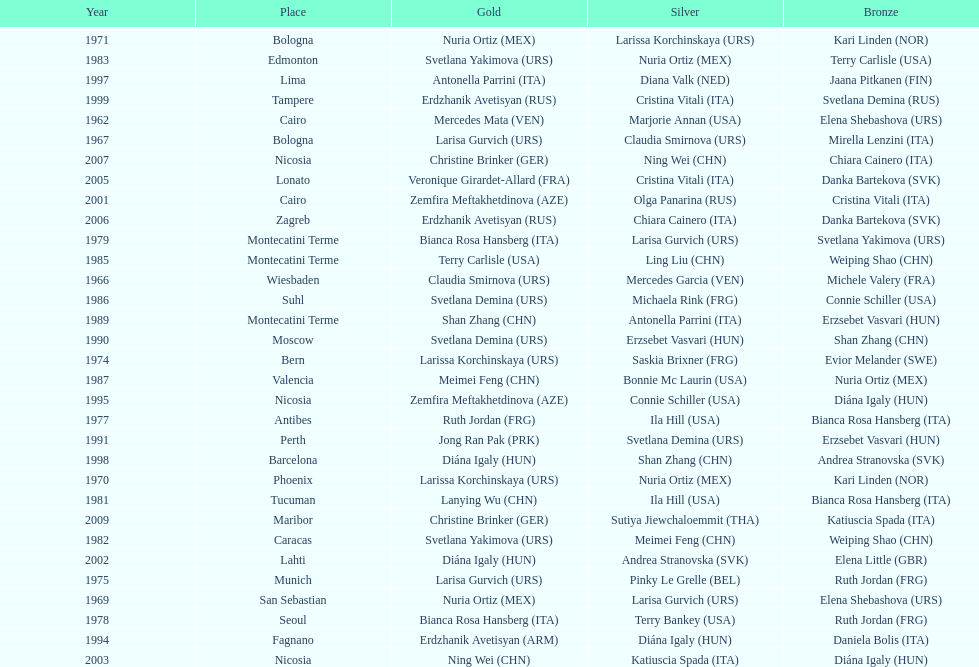Which country has won more gold medals: china or mexico? China. 